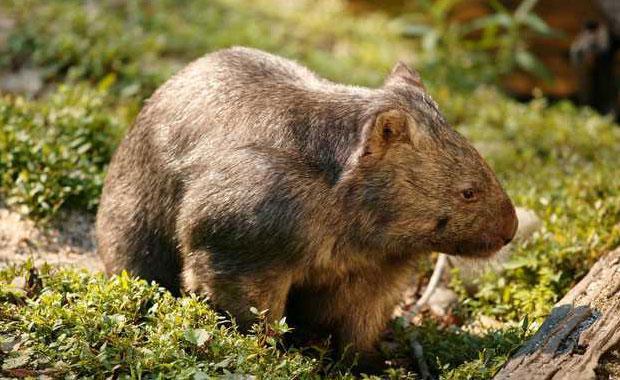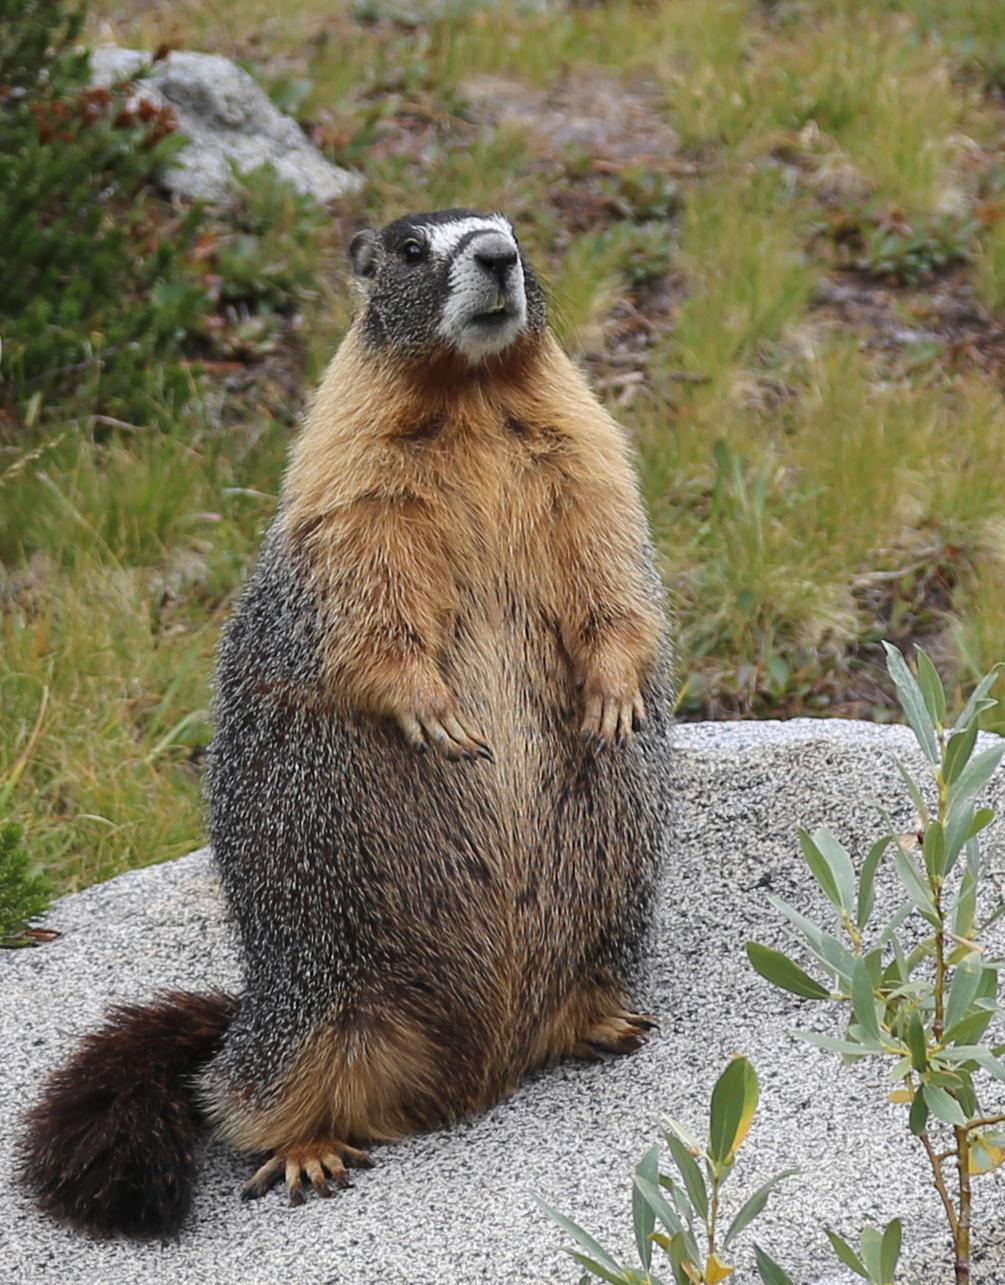The first image is the image on the left, the second image is the image on the right. Given the left and right images, does the statement "Marmot in right image is standing up with arms dangling in front." hold true? Answer yes or no. Yes. The first image is the image on the left, the second image is the image on the right. Examine the images to the left and right. Is the description "the animal in the image on the left is facing right" accurate? Answer yes or no. Yes. 